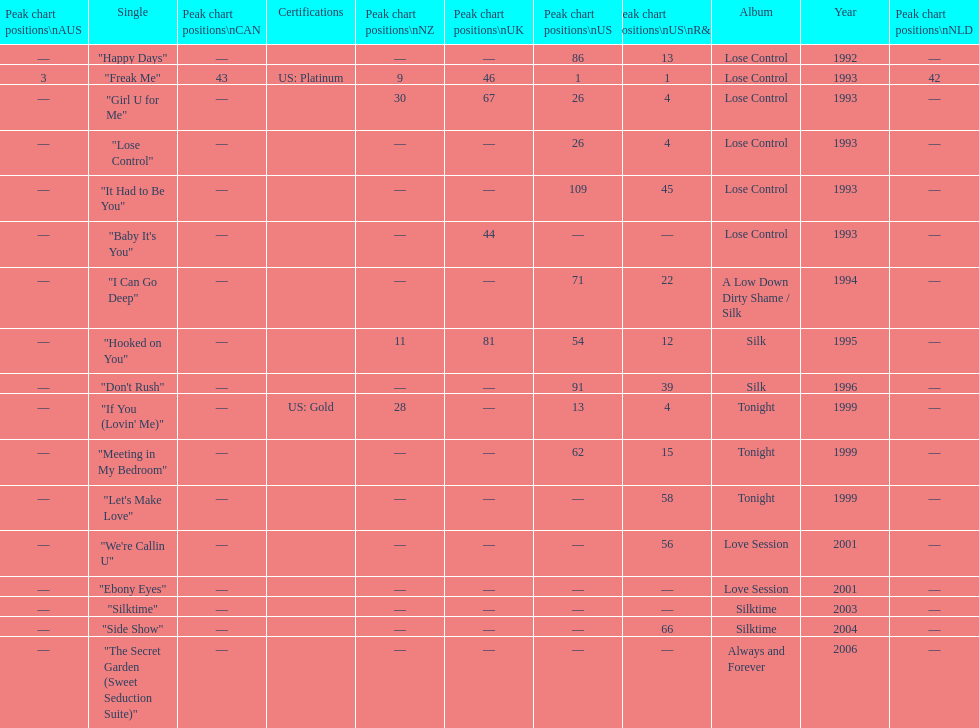Which single is the most in terms of how many times it charted? "Freak Me". 